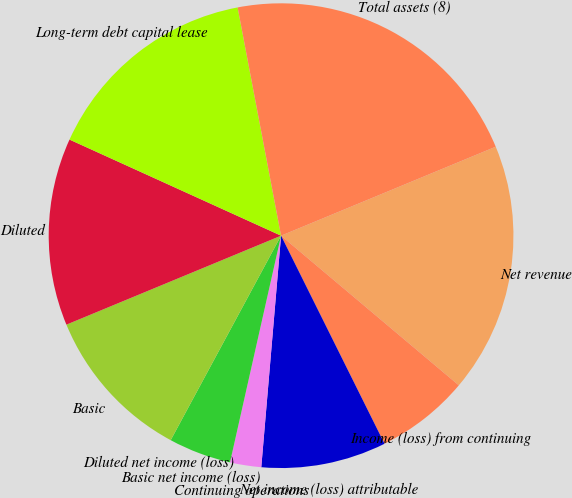Convert chart. <chart><loc_0><loc_0><loc_500><loc_500><pie_chart><fcel>Net revenue<fcel>Income (loss) from continuing<fcel>Net income (loss) attributable<fcel>Continuing operations<fcel>Basic net income (loss)<fcel>Diluted net income (loss)<fcel>Basic<fcel>Diluted<fcel>Long-term debt capital lease<fcel>Total assets (8)<nl><fcel>17.39%<fcel>6.52%<fcel>8.7%<fcel>2.17%<fcel>4.35%<fcel>0.0%<fcel>10.87%<fcel>13.04%<fcel>15.22%<fcel>21.74%<nl></chart> 